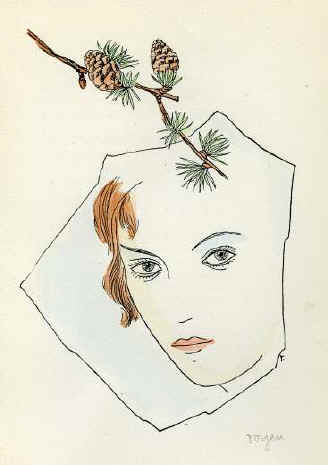What might the pine cones symbolize in this portrait? The pine cones positioned atop the woman's head could symbolize several concepts. In art, pine cones often represent eternal life or regeneration, reflecting their role in the natural life cycle of pine trees. Placing them in such proximity to the human subject might suggest themes of human growth, renewal, or perhaps a deep, intrinsic connection between humans and nature. This element encourages viewers to ponder on the cyclical nature of life and our place within it. 